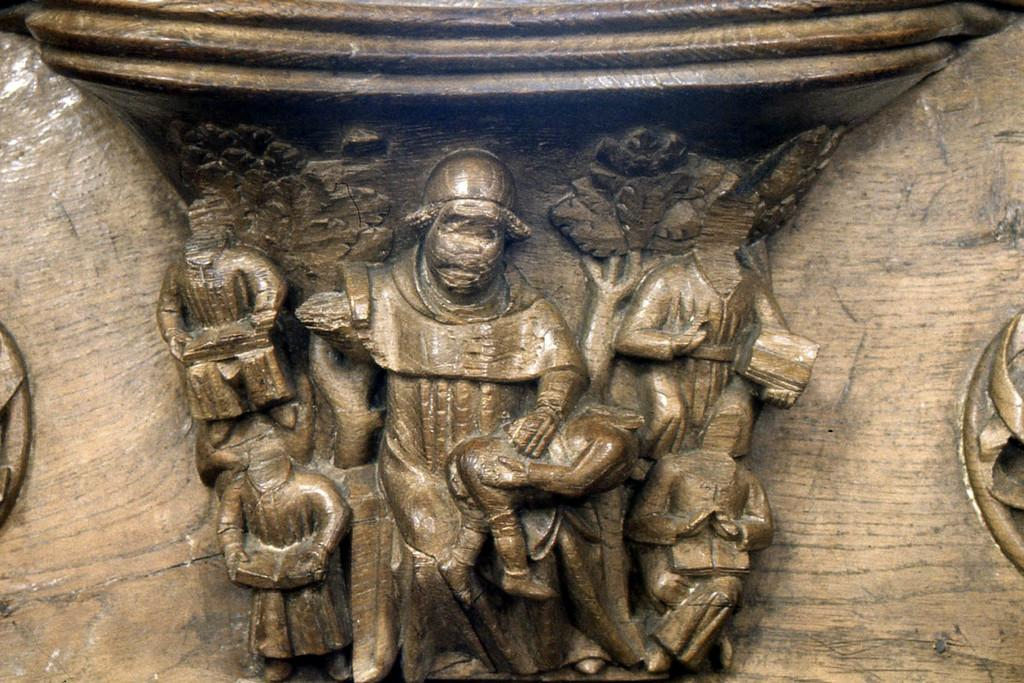What type of objects can be seen in the image? There are sculptures in the image. Can you describe the sculptures in more detail? Unfortunately, the provided facts do not offer any additional details about the sculptures. Are there any other elements in the image besides the sculptures? The given facts do not mention any other elements in the image. How many yaks are present on the island in the image? There are no yaks or islands present in the image; it only features sculptures. 